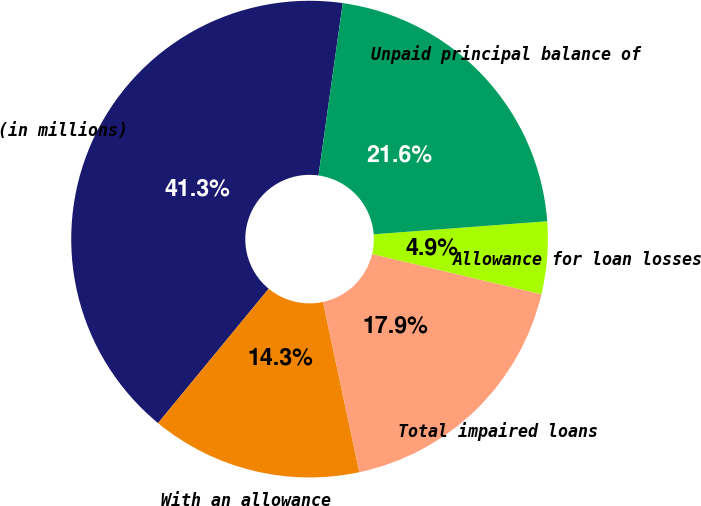Convert chart to OTSL. <chart><loc_0><loc_0><loc_500><loc_500><pie_chart><fcel>(in millions)<fcel>With an allowance<fcel>Total impaired loans<fcel>Allowance for loan losses<fcel>Unpaid principal balance of<nl><fcel>41.26%<fcel>14.31%<fcel>17.94%<fcel>4.91%<fcel>21.58%<nl></chart> 